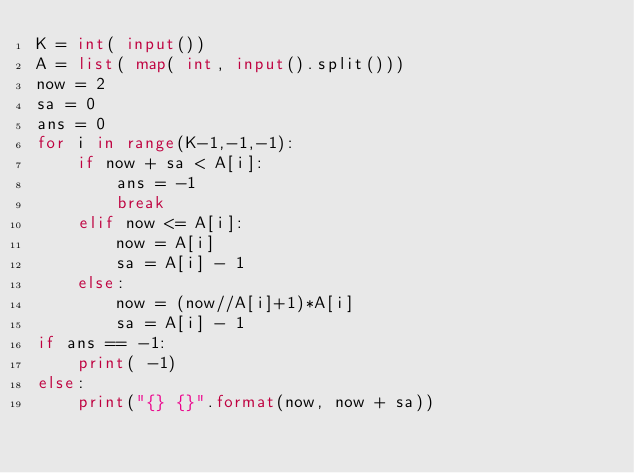Convert code to text. <code><loc_0><loc_0><loc_500><loc_500><_Python_>K = int( input())
A = list( map( int, input().split()))
now = 2
sa = 0
ans = 0
for i in range(K-1,-1,-1):
    if now + sa < A[i]:
        ans = -1
        break
    elif now <= A[i]:
        now = A[i]
        sa = A[i] - 1
    else:
        now = (now//A[i]+1)*A[i]
        sa = A[i] - 1
if ans == -1:
    print( -1)
else:
    print("{} {}".format(now, now + sa))
</code> 